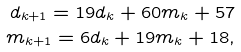Convert formula to latex. <formula><loc_0><loc_0><loc_500><loc_500>d _ { k + 1 } = 1 9 d _ { k } + 6 0 m _ { k } + 5 7 \\ m _ { k + 1 } = 6 d _ { k } + 1 9 m _ { k } + 1 8 ,</formula> 